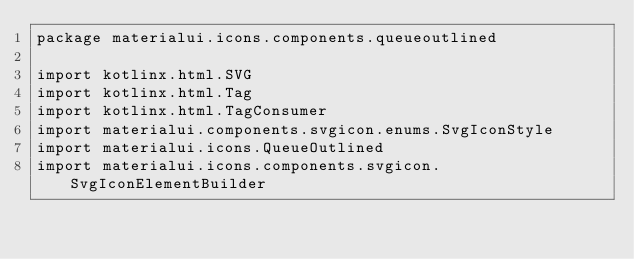Convert code to text. <code><loc_0><loc_0><loc_500><loc_500><_Kotlin_>package materialui.icons.components.queueoutlined

import kotlinx.html.SVG
import kotlinx.html.Tag
import kotlinx.html.TagConsumer
import materialui.components.svgicon.enums.SvgIconStyle
import materialui.icons.QueueOutlined
import materialui.icons.components.svgicon.SvgIconElementBuilder</code> 